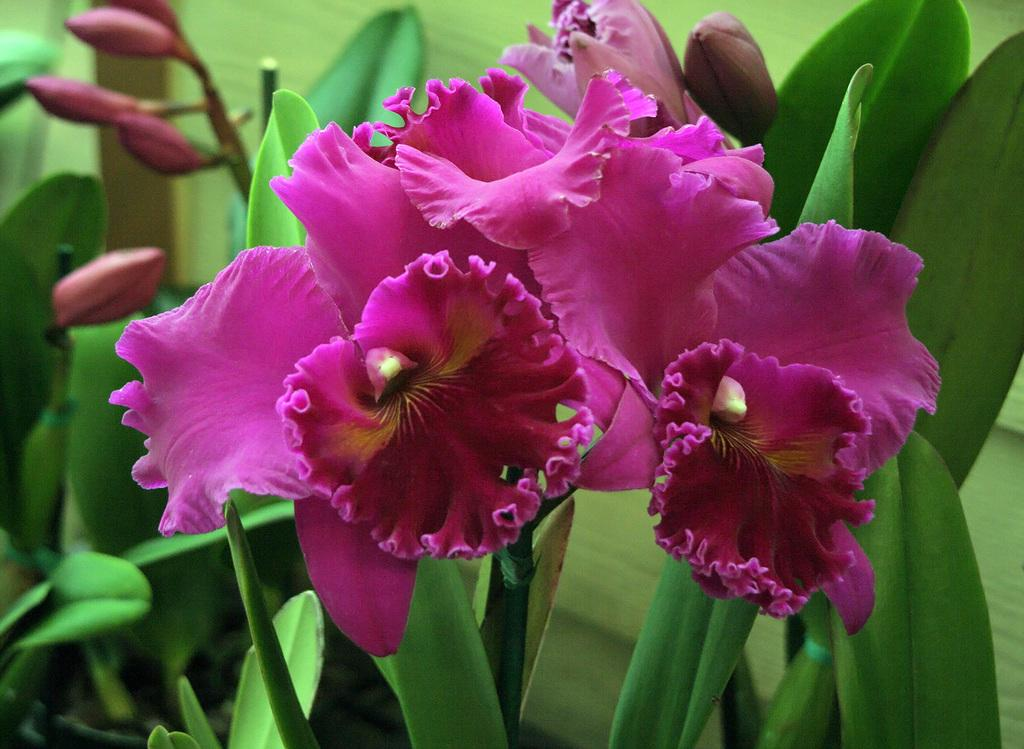What color are the flowers in the image? The flowers in the image are pink in color. What stage of growth are the plants in the image? The plants in the image have buds, indicating that they are in the process of blooming. What color are the plants in the image? The plants in the image are green in color. What type of sign can be seen in the image? There is no sign present in the image; it features pink flowers and green plants. How many family members are visible in the image? There are no family members present in the image; it features pink flowers and green plants. 